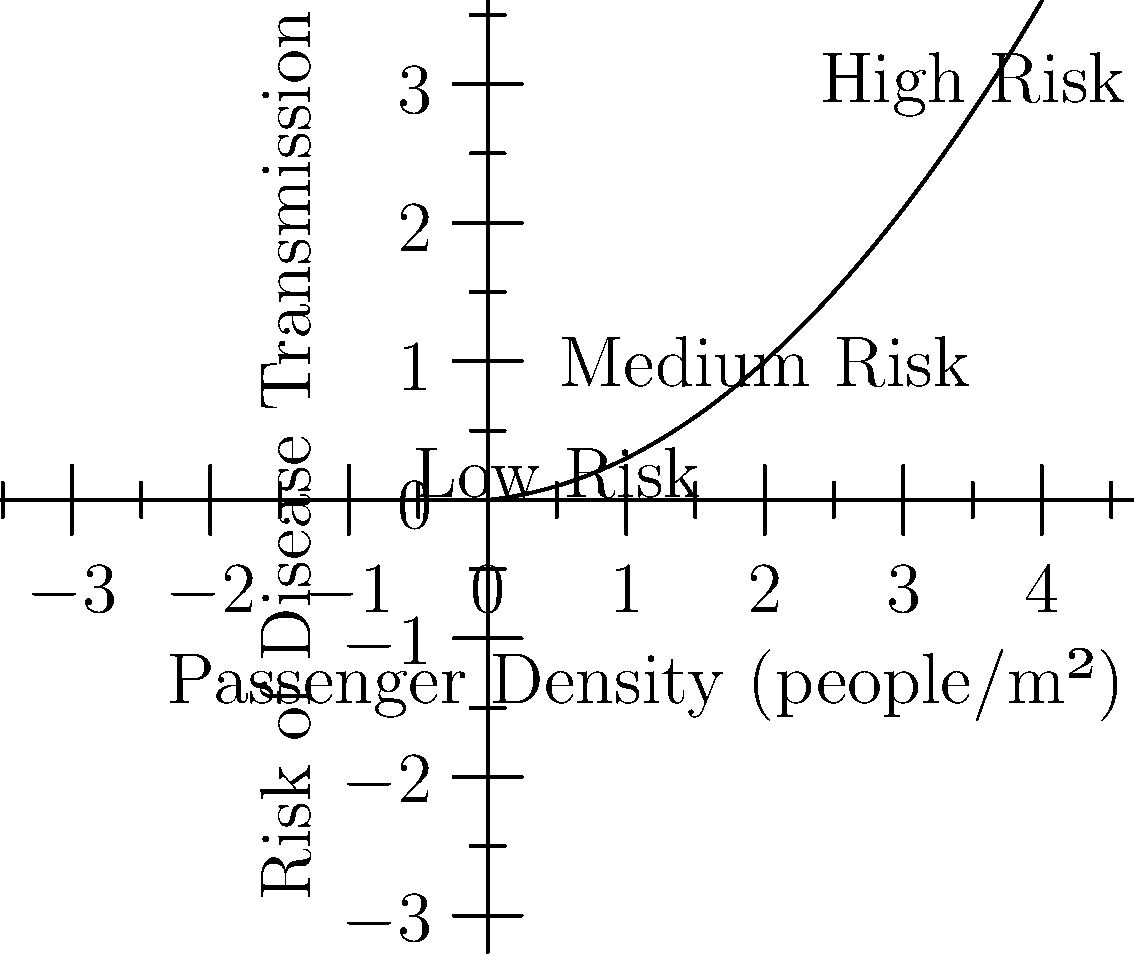Based on the graph showing the relationship between passenger density and risk of disease transmission in public transportation, what design strategy would be most effective in reducing the risk of disease spread while maintaining system efficiency? To answer this question, let's analyze the graph and consider the implications for public transportation design:

1. Observe the curve: The graph shows a non-linear relationship between passenger density and disease transmission risk. As density increases, the risk rises more rapidly.

2. Identify risk zones:
   - Low risk: 0-1 people/m²
   - Medium risk: 1-2.5 people/m²
   - High risk: >2.5 people/m²

3. Consider efficiency: We need to balance risk reduction with maintaining system efficiency.

4. Optimal strategy: Aim to keep passenger density in the low to medium risk range (1-2 people/m²) by:
   a) Increasing the frequency of vehicles to reduce crowding
   b) Implementing capacity limits on vehicles
   c) Redesigning interiors to maximize space utilization

5. Additional measures:
   - Improve ventilation systems
   - Install physical barriers between seats
   - Encourage off-peak travel

6. Conclusion: The most effective strategy is to design the system to maintain passenger density below 2 people/m², striking a balance between risk reduction and efficiency.
Answer: Design for 1-2 people/m² density 